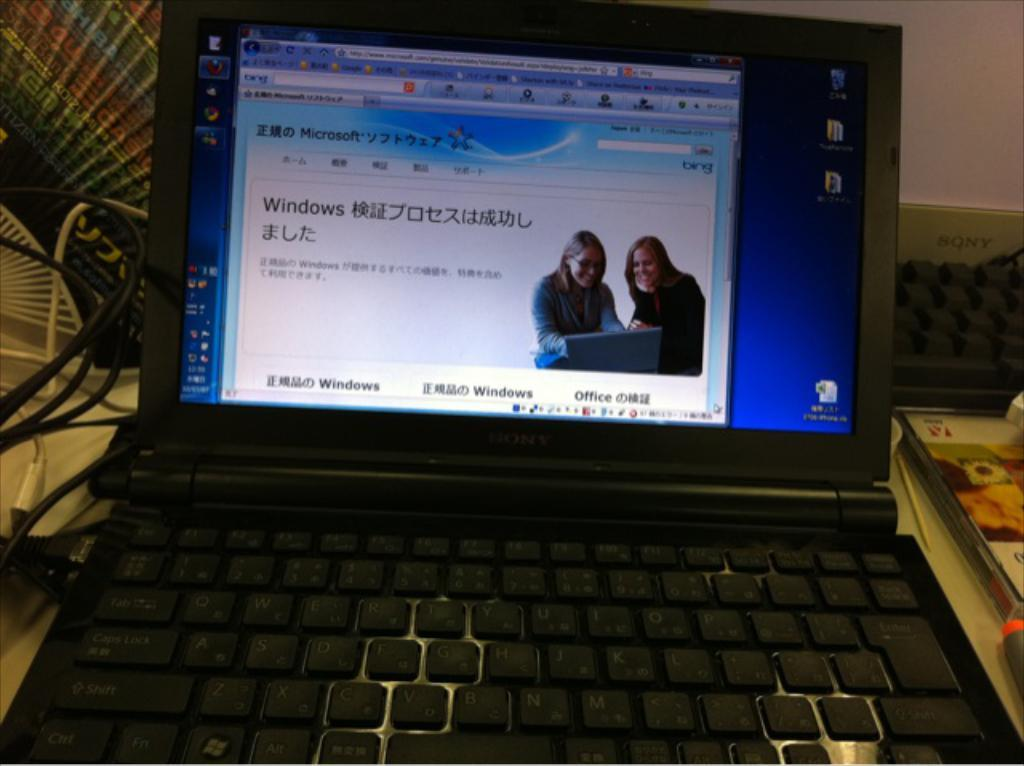<image>
Describe the image concisely. Black laptop with a screen showing Microsoft and Windows. 